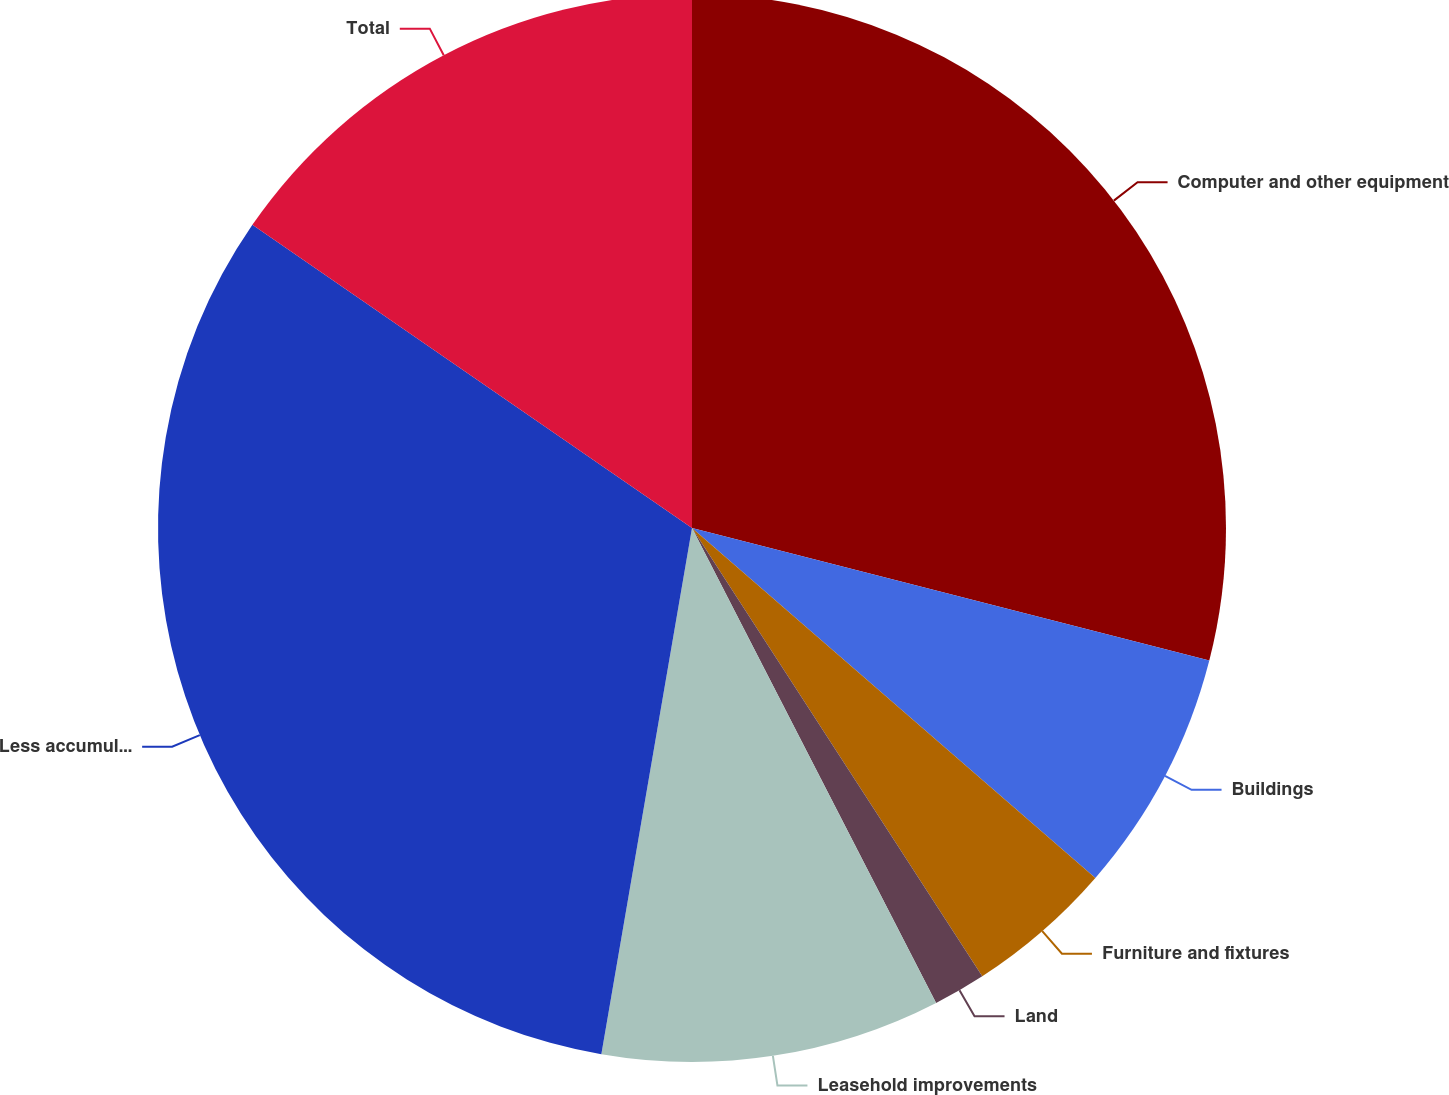Convert chart to OTSL. <chart><loc_0><loc_0><loc_500><loc_500><pie_chart><fcel>Computer and other equipment<fcel>Buildings<fcel>Furniture and fixtures<fcel>Land<fcel>Leasehold improvements<fcel>Less accumulated depreciation<fcel>Total<nl><fcel>28.99%<fcel>7.38%<fcel>4.48%<fcel>1.59%<fcel>10.27%<fcel>31.89%<fcel>15.39%<nl></chart> 